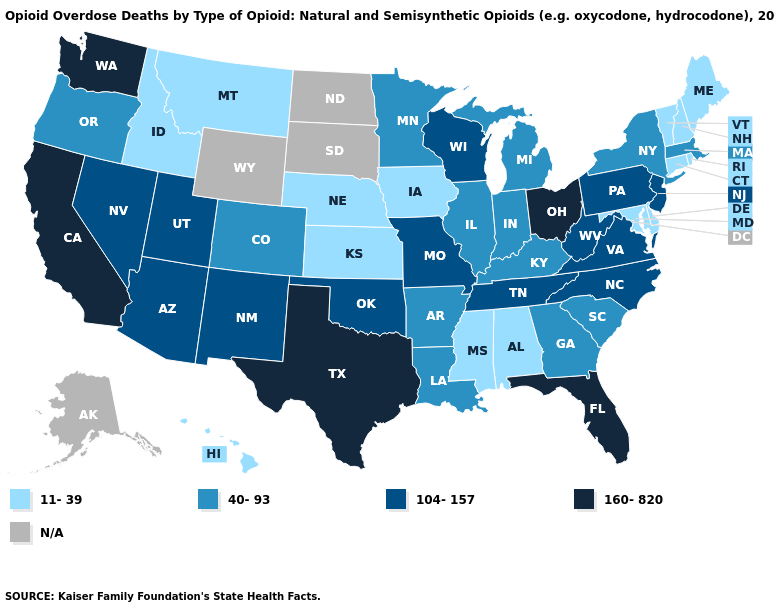Is the legend a continuous bar?
Short answer required. No. What is the lowest value in states that border Delaware?
Write a very short answer. 11-39. Which states have the lowest value in the USA?
Quick response, please. Alabama, Connecticut, Delaware, Hawaii, Idaho, Iowa, Kansas, Maine, Maryland, Mississippi, Montana, Nebraska, New Hampshire, Rhode Island, Vermont. What is the lowest value in the Northeast?
Be succinct. 11-39. What is the value of Wyoming?
Short answer required. N/A. What is the value of Missouri?
Short answer required. 104-157. Does Iowa have the highest value in the USA?
Be succinct. No. What is the value of Kentucky?
Answer briefly. 40-93. Name the states that have a value in the range N/A?
Short answer required. Alaska, North Dakota, South Dakota, Wyoming. Which states have the highest value in the USA?
Write a very short answer. California, Florida, Ohio, Texas, Washington. What is the lowest value in the MidWest?
Answer briefly. 11-39. Name the states that have a value in the range 104-157?
Quick response, please. Arizona, Missouri, Nevada, New Jersey, New Mexico, North Carolina, Oklahoma, Pennsylvania, Tennessee, Utah, Virginia, West Virginia, Wisconsin. Which states have the highest value in the USA?
Concise answer only. California, Florida, Ohio, Texas, Washington. Name the states that have a value in the range N/A?
Concise answer only. Alaska, North Dakota, South Dakota, Wyoming. What is the highest value in states that border Illinois?
Quick response, please. 104-157. 